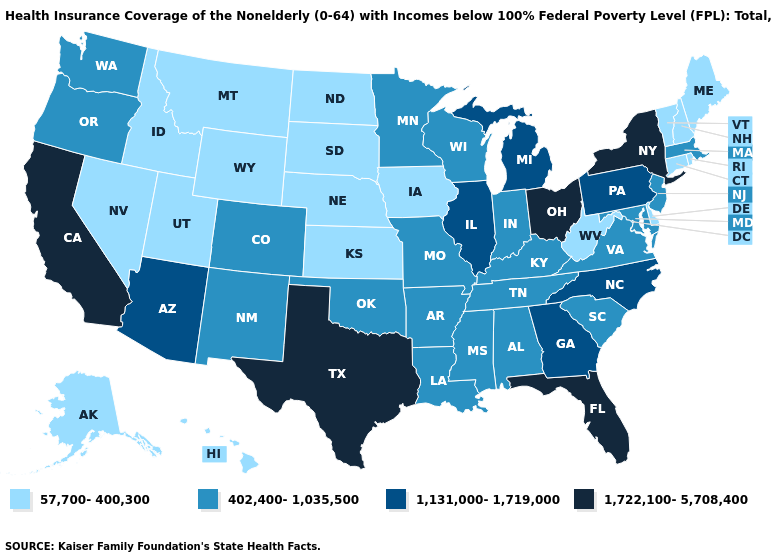Name the states that have a value in the range 402,400-1,035,500?
Concise answer only. Alabama, Arkansas, Colorado, Indiana, Kentucky, Louisiana, Maryland, Massachusetts, Minnesota, Mississippi, Missouri, New Jersey, New Mexico, Oklahoma, Oregon, South Carolina, Tennessee, Virginia, Washington, Wisconsin. Name the states that have a value in the range 402,400-1,035,500?
Answer briefly. Alabama, Arkansas, Colorado, Indiana, Kentucky, Louisiana, Maryland, Massachusetts, Minnesota, Mississippi, Missouri, New Jersey, New Mexico, Oklahoma, Oregon, South Carolina, Tennessee, Virginia, Washington, Wisconsin. Among the states that border Minnesota , does Wisconsin have the lowest value?
Short answer required. No. What is the lowest value in the South?
Concise answer only. 57,700-400,300. Among the states that border Tennessee , does Kentucky have the highest value?
Be succinct. No. Name the states that have a value in the range 402,400-1,035,500?
Keep it brief. Alabama, Arkansas, Colorado, Indiana, Kentucky, Louisiana, Maryland, Massachusetts, Minnesota, Mississippi, Missouri, New Jersey, New Mexico, Oklahoma, Oregon, South Carolina, Tennessee, Virginia, Washington, Wisconsin. Which states have the lowest value in the West?
Write a very short answer. Alaska, Hawaii, Idaho, Montana, Nevada, Utah, Wyoming. Name the states that have a value in the range 1,722,100-5,708,400?
Write a very short answer. California, Florida, New York, Ohio, Texas. Name the states that have a value in the range 57,700-400,300?
Keep it brief. Alaska, Connecticut, Delaware, Hawaii, Idaho, Iowa, Kansas, Maine, Montana, Nebraska, Nevada, New Hampshire, North Dakota, Rhode Island, South Dakota, Utah, Vermont, West Virginia, Wyoming. Among the states that border Delaware , does New Jersey have the highest value?
Keep it brief. No. Does Michigan have the highest value in the MidWest?
Quick response, please. No. What is the value of Rhode Island?
Concise answer only. 57,700-400,300. What is the value of Oklahoma?
Be succinct. 402,400-1,035,500. Among the states that border Arkansas , which have the highest value?
Give a very brief answer. Texas. Which states have the highest value in the USA?
Short answer required. California, Florida, New York, Ohio, Texas. 